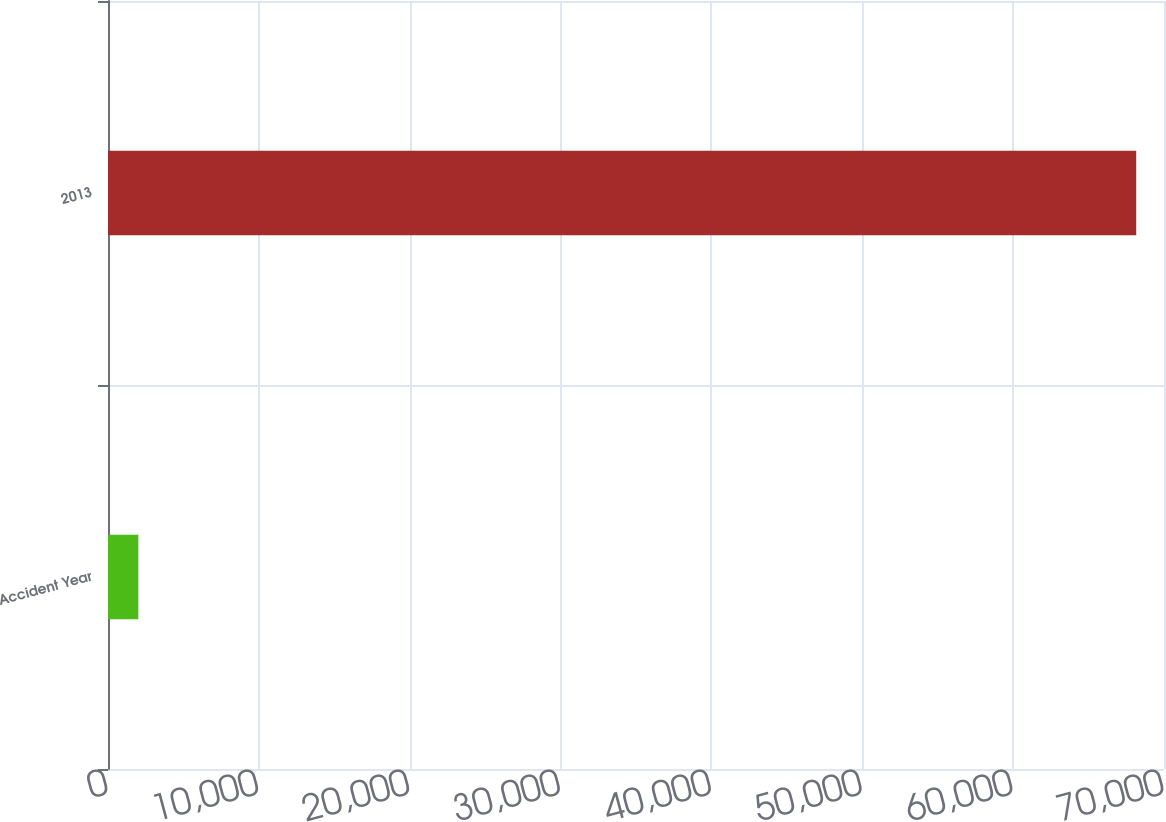Convert chart. <chart><loc_0><loc_0><loc_500><loc_500><bar_chart><fcel>Accident Year<fcel>2013<nl><fcel>2013<fcel>68159<nl></chart> 